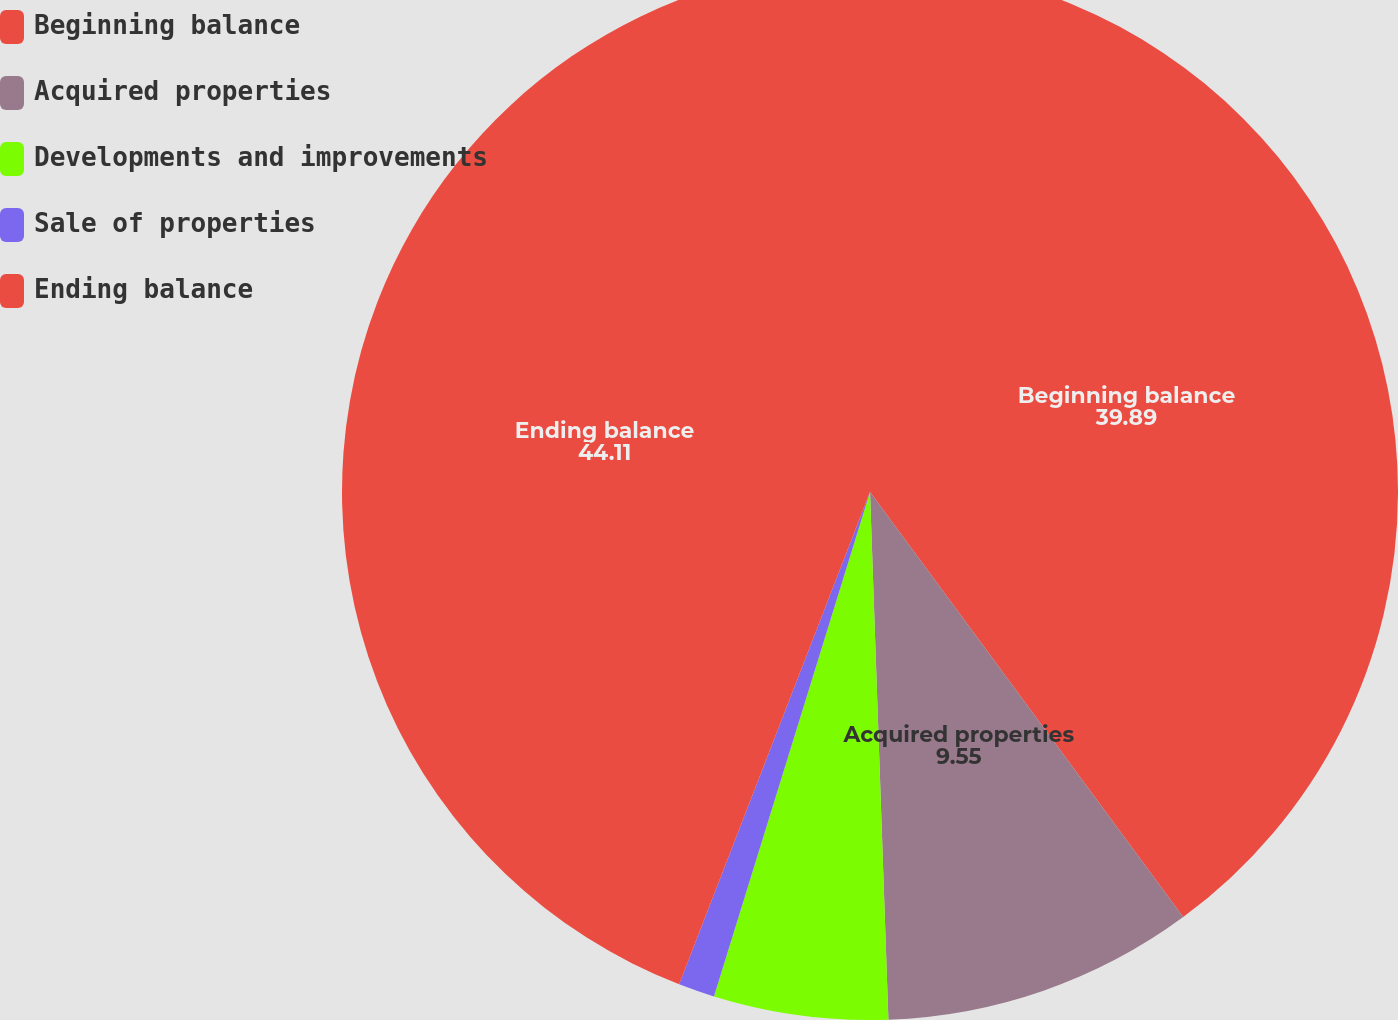Convert chart to OTSL. <chart><loc_0><loc_0><loc_500><loc_500><pie_chart><fcel>Beginning balance<fcel>Acquired properties<fcel>Developments and improvements<fcel>Sale of properties<fcel>Ending balance<nl><fcel>39.89%<fcel>9.55%<fcel>5.33%<fcel>1.11%<fcel>44.11%<nl></chart> 